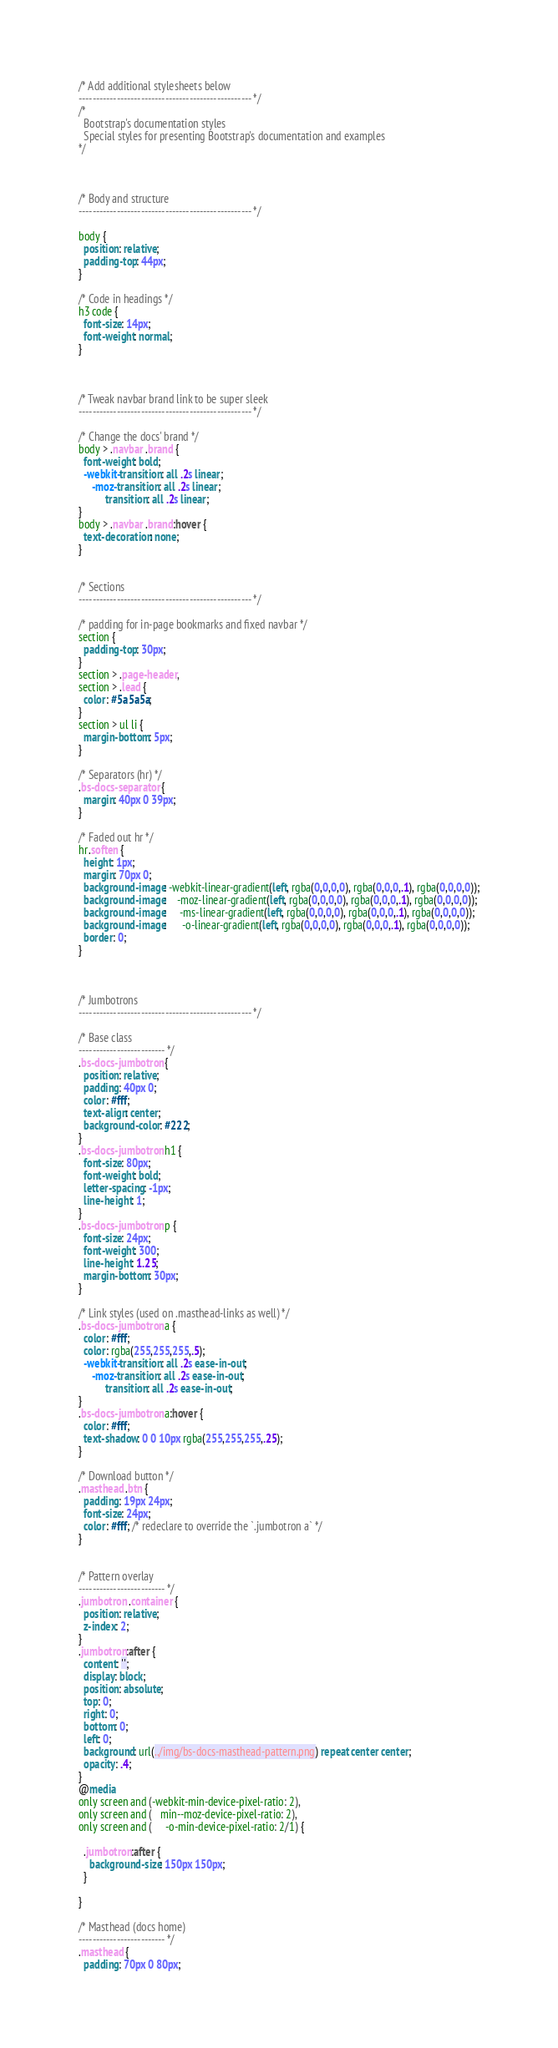Convert code to text. <code><loc_0><loc_0><loc_500><loc_500><_CSS_>/* Add additional stylesheets below
-------------------------------------------------- */
/*
  Bootstrap's documentation styles
  Special styles for presenting Bootstrap's documentation and examples
*/



/* Body and structure
-------------------------------------------------- */

body {
  position: relative;
  padding-top: 44px;
}

/* Code in headings */
h3 code {
  font-size: 14px;
  font-weight: normal;
}



/* Tweak navbar brand link to be super sleek
-------------------------------------------------- */

/* Change the docs' brand */
body > .navbar .brand {
  font-weight: bold;
  -webkit-transition: all .2s linear;
     -moz-transition: all .2s linear;
          transition: all .2s linear;
}
body > .navbar .brand:hover {
  text-decoration: none;
}


/* Sections
-------------------------------------------------- */

/* padding for in-page bookmarks and fixed navbar */
section {
  padding-top: 30px;
}
section > .page-header,
section > .lead {
  color: #5a5a5a;
}
section > ul li {
  margin-bottom: 5px;
}

/* Separators (hr) */
.bs-docs-separator {
  margin: 40px 0 39px;
}

/* Faded out hr */
hr.soften {
  height: 1px;
  margin: 70px 0;
  background-image: -webkit-linear-gradient(left, rgba(0,0,0,0), rgba(0,0,0,.1), rgba(0,0,0,0));
  background-image:    -moz-linear-gradient(left, rgba(0,0,0,0), rgba(0,0,0,.1), rgba(0,0,0,0));
  background-image:     -ms-linear-gradient(left, rgba(0,0,0,0), rgba(0,0,0,.1), rgba(0,0,0,0));
  background-image:      -o-linear-gradient(left, rgba(0,0,0,0), rgba(0,0,0,.1), rgba(0,0,0,0));
  border: 0;
}



/* Jumbotrons
-------------------------------------------------- */

/* Base class
------------------------- */
.bs-docs-jumbotron {
  position: relative;
  padding: 40px 0;
  color: #fff;
  text-align: center;
  background-color: #222;
}
.bs-docs-jumbotron h1 {
  font-size: 80px;
  font-weight: bold;
  letter-spacing: -1px;
  line-height: 1;
}
.bs-docs-jumbotron p {
  font-size: 24px;
  font-weight: 300;
  line-height: 1.25;
  margin-bottom: 30px;
}

/* Link styles (used on .masthead-links as well) */
.bs-docs-jumbotron a {
  color: #fff;
  color: rgba(255,255,255,.5);
  -webkit-transition: all .2s ease-in-out;
     -moz-transition: all .2s ease-in-out;
          transition: all .2s ease-in-out;
}
.bs-docs-jumbotron a:hover {
  color: #fff;
  text-shadow: 0 0 10px rgba(255,255,255,.25);
}

/* Download button */
.masthead .btn {
  padding: 19px 24px;
  font-size: 24px;
  color: #fff; /* redeclare to override the `.jumbotron a` */
}


/* Pattern overlay
------------------------- */
.jumbotron .container {
  position: relative;
  z-index: 2;
}
.jumbotron:after {
  content: '';
  display: block;
  position: absolute;
  top: 0;
  right: 0;
  bottom: 0;
  left: 0;
  background: url(../img/bs-docs-masthead-pattern.png) repeat center center;
  opacity: .4;
}
@media
only screen and (-webkit-min-device-pixel-ratio: 2),
only screen and (   min--moz-device-pixel-ratio: 2),
only screen and (     -o-min-device-pixel-ratio: 2/1) {

  .jumbotron:after {
    background-size: 150px 150px;
  }

}

/* Masthead (docs home)
------------------------- */
.masthead {
  padding: 70px 0 80px;</code> 